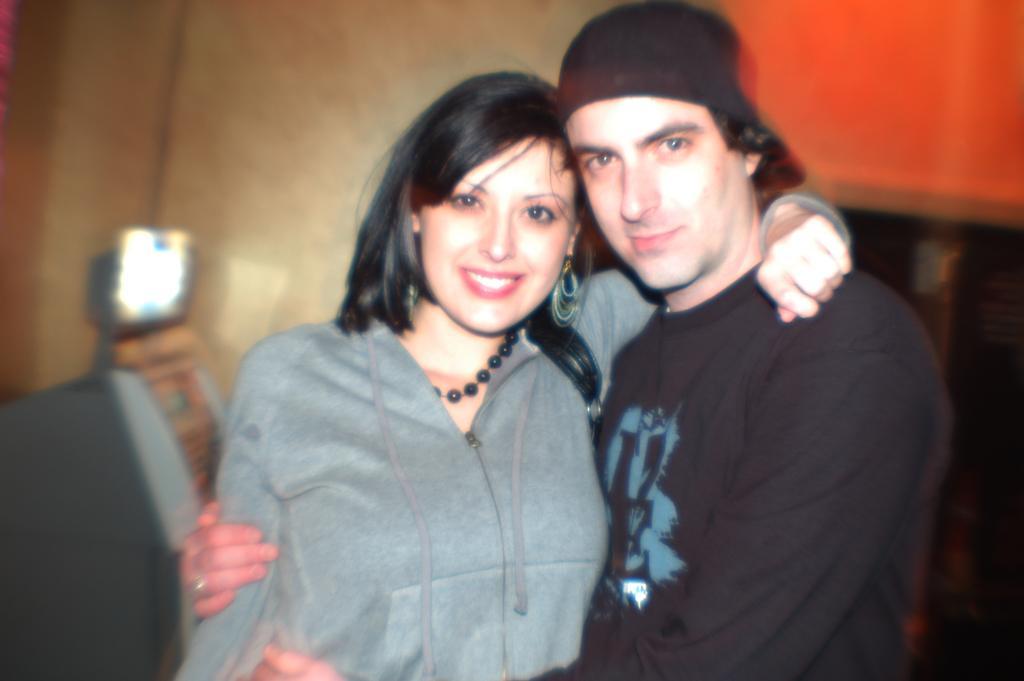Can you describe this image briefly? In the picture I can see a man and a woman are standing and smiling. In the background I can see a wall and some other objects. The background of the image is blurred. 